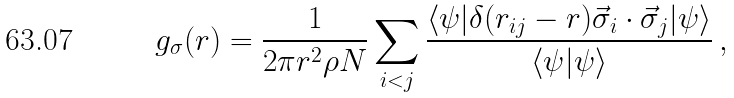<formula> <loc_0><loc_0><loc_500><loc_500>g _ { \sigma } ( r ) = \frac { 1 } { 2 \pi r ^ { 2 } \rho N } \sum _ { i < j } \frac { \langle \psi | \delta ( r _ { i j } - r ) \vec { \sigma } _ { i } \cdot \vec { \sigma } _ { j } | \psi \rangle } { \langle \psi | \psi \rangle } \, ,</formula> 